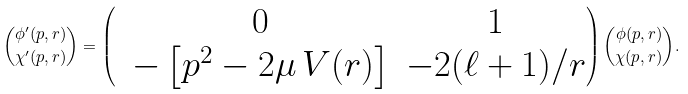Convert formula to latex. <formula><loc_0><loc_0><loc_500><loc_500>\binom { \phi ^ { \prime } ( p , r ) } { \chi ^ { \prime } ( p , r ) } = \begin{pmatrix} & 0 & 1 \\ & - \left [ p ^ { 2 } - 2 \mu \, V ( r ) \right ] & - 2 ( \ell + 1 ) / r \end{pmatrix} \binom { \phi ( p , r ) } { \chi ( p , r ) } .</formula> 